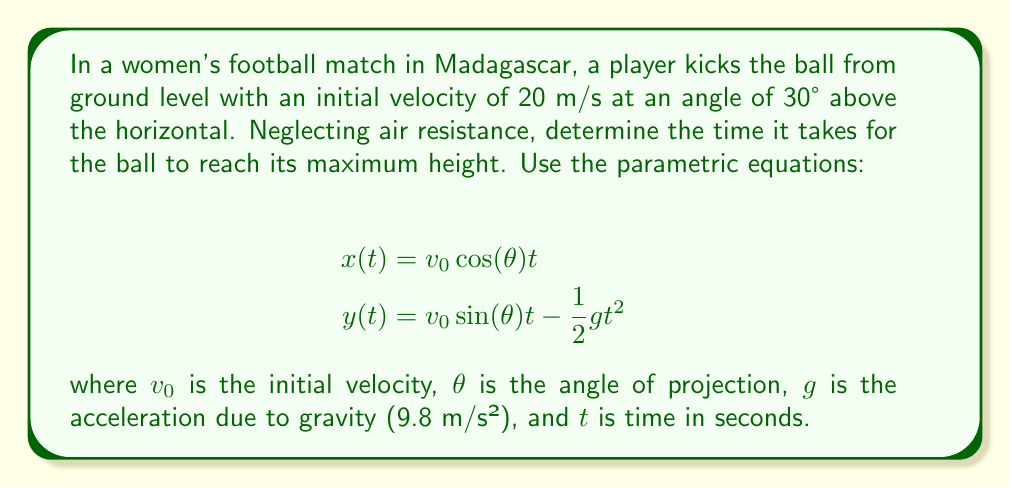Solve this math problem. To find the time when the ball reaches its maximum height, we need to determine when the vertical velocity becomes zero. We can do this by following these steps:

1) The vertical velocity component is given by the derivative of $y(t)$ with respect to $t$:

   $$\frac{dy}{dt} = v_0 \sin(\theta) - gt$$

2) At the highest point, $\frac{dy}{dt} = 0$. So we set this equal to zero and solve for $t$:

   $$0 = v_0 \sin(\theta) - gt$$
   $$gt = v_0 \sin(\theta)$$
   $$t = \frac{v_0 \sin(\theta)}{g}$$

3) Now we substitute the given values:
   $v_0 = 20$ m/s
   $\theta = 30°$
   $g = 9.8$ m/s²

4) Calculate $\sin(30°)$:
   $\sin(30°) = 0.5$

5) Plug these values into our equation:

   $$t = \frac{20 \cdot 0.5}{9.8} = \frac{10}{9.8} \approx 1.02$$

Therefore, the ball reaches its maximum height after approximately 1.02 seconds.
Answer: 1.02 seconds 